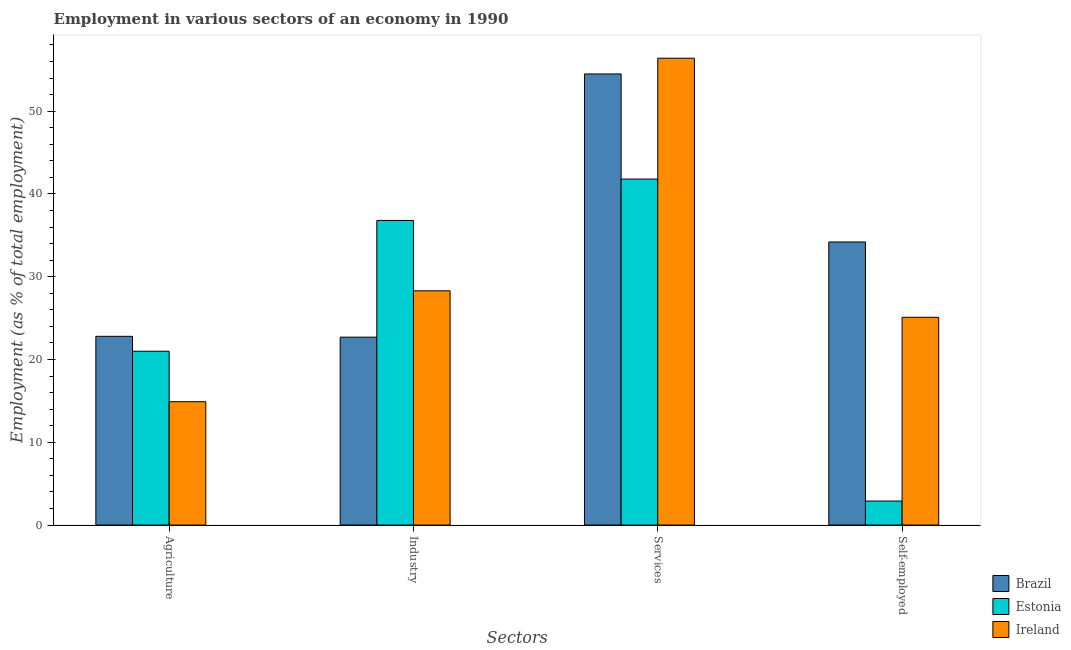Are the number of bars per tick equal to the number of legend labels?
Provide a succinct answer. Yes. Are the number of bars on each tick of the X-axis equal?
Your answer should be compact. Yes. How many bars are there on the 1st tick from the right?
Your answer should be very brief. 3. What is the label of the 4th group of bars from the left?
Your answer should be compact. Self-employed. What is the percentage of workers in industry in Ireland?
Your answer should be compact. 28.3. Across all countries, what is the maximum percentage of workers in agriculture?
Keep it short and to the point. 22.8. Across all countries, what is the minimum percentage of workers in services?
Provide a succinct answer. 41.8. In which country was the percentage of workers in industry maximum?
Keep it short and to the point. Estonia. In which country was the percentage of workers in agriculture minimum?
Offer a very short reply. Ireland. What is the total percentage of self employed workers in the graph?
Your answer should be very brief. 62.2. What is the difference between the percentage of workers in industry in Brazil and that in Estonia?
Give a very brief answer. -14.1. What is the difference between the percentage of workers in industry in Ireland and the percentage of self employed workers in Estonia?
Provide a succinct answer. 25.4. What is the average percentage of workers in industry per country?
Make the answer very short. 29.27. What is the difference between the percentage of workers in industry and percentage of workers in agriculture in Ireland?
Your answer should be very brief. 13.4. What is the ratio of the percentage of workers in agriculture in Estonia to that in Ireland?
Provide a short and direct response. 1.41. Is the difference between the percentage of workers in agriculture in Estonia and Ireland greater than the difference between the percentage of workers in services in Estonia and Ireland?
Make the answer very short. Yes. What is the difference between the highest and the second highest percentage of workers in industry?
Give a very brief answer. 8.5. What is the difference between the highest and the lowest percentage of workers in services?
Keep it short and to the point. 14.6. In how many countries, is the percentage of workers in services greater than the average percentage of workers in services taken over all countries?
Offer a very short reply. 2. Is the sum of the percentage of workers in services in Estonia and Brazil greater than the maximum percentage of self employed workers across all countries?
Offer a terse response. Yes. What does the 2nd bar from the left in Industry represents?
Keep it short and to the point. Estonia. What does the 2nd bar from the right in Agriculture represents?
Your answer should be very brief. Estonia. Is it the case that in every country, the sum of the percentage of workers in agriculture and percentage of workers in industry is greater than the percentage of workers in services?
Your answer should be compact. No. Are all the bars in the graph horizontal?
Your answer should be compact. No. How many countries are there in the graph?
Provide a succinct answer. 3. What is the difference between two consecutive major ticks on the Y-axis?
Keep it short and to the point. 10. Does the graph contain grids?
Provide a short and direct response. No. Where does the legend appear in the graph?
Give a very brief answer. Bottom right. How many legend labels are there?
Your answer should be very brief. 3. What is the title of the graph?
Provide a short and direct response. Employment in various sectors of an economy in 1990. Does "Belarus" appear as one of the legend labels in the graph?
Make the answer very short. No. What is the label or title of the X-axis?
Offer a very short reply. Sectors. What is the label or title of the Y-axis?
Keep it short and to the point. Employment (as % of total employment). What is the Employment (as % of total employment) of Brazil in Agriculture?
Your answer should be compact. 22.8. What is the Employment (as % of total employment) in Estonia in Agriculture?
Keep it short and to the point. 21. What is the Employment (as % of total employment) in Ireland in Agriculture?
Give a very brief answer. 14.9. What is the Employment (as % of total employment) of Brazil in Industry?
Offer a very short reply. 22.7. What is the Employment (as % of total employment) of Estonia in Industry?
Provide a succinct answer. 36.8. What is the Employment (as % of total employment) in Ireland in Industry?
Offer a very short reply. 28.3. What is the Employment (as % of total employment) of Brazil in Services?
Ensure brevity in your answer.  54.5. What is the Employment (as % of total employment) in Estonia in Services?
Keep it short and to the point. 41.8. What is the Employment (as % of total employment) in Ireland in Services?
Provide a short and direct response. 56.4. What is the Employment (as % of total employment) of Brazil in Self-employed?
Give a very brief answer. 34.2. What is the Employment (as % of total employment) of Estonia in Self-employed?
Provide a succinct answer. 2.9. What is the Employment (as % of total employment) in Ireland in Self-employed?
Ensure brevity in your answer.  25.1. Across all Sectors, what is the maximum Employment (as % of total employment) of Brazil?
Your answer should be compact. 54.5. Across all Sectors, what is the maximum Employment (as % of total employment) in Estonia?
Your answer should be very brief. 41.8. Across all Sectors, what is the maximum Employment (as % of total employment) of Ireland?
Provide a short and direct response. 56.4. Across all Sectors, what is the minimum Employment (as % of total employment) in Brazil?
Offer a very short reply. 22.7. Across all Sectors, what is the minimum Employment (as % of total employment) of Estonia?
Keep it short and to the point. 2.9. Across all Sectors, what is the minimum Employment (as % of total employment) of Ireland?
Your answer should be very brief. 14.9. What is the total Employment (as % of total employment) in Brazil in the graph?
Offer a very short reply. 134.2. What is the total Employment (as % of total employment) in Estonia in the graph?
Provide a short and direct response. 102.5. What is the total Employment (as % of total employment) in Ireland in the graph?
Your answer should be compact. 124.7. What is the difference between the Employment (as % of total employment) of Estonia in Agriculture and that in Industry?
Ensure brevity in your answer.  -15.8. What is the difference between the Employment (as % of total employment) in Ireland in Agriculture and that in Industry?
Ensure brevity in your answer.  -13.4. What is the difference between the Employment (as % of total employment) of Brazil in Agriculture and that in Services?
Provide a short and direct response. -31.7. What is the difference between the Employment (as % of total employment) in Estonia in Agriculture and that in Services?
Your answer should be compact. -20.8. What is the difference between the Employment (as % of total employment) of Ireland in Agriculture and that in Services?
Give a very brief answer. -41.5. What is the difference between the Employment (as % of total employment) in Ireland in Agriculture and that in Self-employed?
Your answer should be compact. -10.2. What is the difference between the Employment (as % of total employment) in Brazil in Industry and that in Services?
Your answer should be very brief. -31.8. What is the difference between the Employment (as % of total employment) of Ireland in Industry and that in Services?
Offer a terse response. -28.1. What is the difference between the Employment (as % of total employment) in Brazil in Industry and that in Self-employed?
Provide a succinct answer. -11.5. What is the difference between the Employment (as % of total employment) of Estonia in Industry and that in Self-employed?
Provide a succinct answer. 33.9. What is the difference between the Employment (as % of total employment) in Ireland in Industry and that in Self-employed?
Ensure brevity in your answer.  3.2. What is the difference between the Employment (as % of total employment) in Brazil in Services and that in Self-employed?
Provide a short and direct response. 20.3. What is the difference between the Employment (as % of total employment) in Estonia in Services and that in Self-employed?
Your answer should be very brief. 38.9. What is the difference between the Employment (as % of total employment) in Ireland in Services and that in Self-employed?
Your response must be concise. 31.3. What is the difference between the Employment (as % of total employment) in Brazil in Agriculture and the Employment (as % of total employment) in Estonia in Industry?
Your response must be concise. -14. What is the difference between the Employment (as % of total employment) in Estonia in Agriculture and the Employment (as % of total employment) in Ireland in Industry?
Your response must be concise. -7.3. What is the difference between the Employment (as % of total employment) in Brazil in Agriculture and the Employment (as % of total employment) in Ireland in Services?
Ensure brevity in your answer.  -33.6. What is the difference between the Employment (as % of total employment) in Estonia in Agriculture and the Employment (as % of total employment) in Ireland in Services?
Make the answer very short. -35.4. What is the difference between the Employment (as % of total employment) of Brazil in Agriculture and the Employment (as % of total employment) of Ireland in Self-employed?
Your response must be concise. -2.3. What is the difference between the Employment (as % of total employment) of Brazil in Industry and the Employment (as % of total employment) of Estonia in Services?
Offer a terse response. -19.1. What is the difference between the Employment (as % of total employment) of Brazil in Industry and the Employment (as % of total employment) of Ireland in Services?
Your answer should be compact. -33.7. What is the difference between the Employment (as % of total employment) in Estonia in Industry and the Employment (as % of total employment) in Ireland in Services?
Offer a terse response. -19.6. What is the difference between the Employment (as % of total employment) in Brazil in Industry and the Employment (as % of total employment) in Estonia in Self-employed?
Your response must be concise. 19.8. What is the difference between the Employment (as % of total employment) in Brazil in Industry and the Employment (as % of total employment) in Ireland in Self-employed?
Offer a terse response. -2.4. What is the difference between the Employment (as % of total employment) in Estonia in Industry and the Employment (as % of total employment) in Ireland in Self-employed?
Your answer should be very brief. 11.7. What is the difference between the Employment (as % of total employment) of Brazil in Services and the Employment (as % of total employment) of Estonia in Self-employed?
Ensure brevity in your answer.  51.6. What is the difference between the Employment (as % of total employment) in Brazil in Services and the Employment (as % of total employment) in Ireland in Self-employed?
Offer a very short reply. 29.4. What is the difference between the Employment (as % of total employment) of Estonia in Services and the Employment (as % of total employment) of Ireland in Self-employed?
Your answer should be very brief. 16.7. What is the average Employment (as % of total employment) in Brazil per Sectors?
Ensure brevity in your answer.  33.55. What is the average Employment (as % of total employment) in Estonia per Sectors?
Your response must be concise. 25.62. What is the average Employment (as % of total employment) in Ireland per Sectors?
Keep it short and to the point. 31.18. What is the difference between the Employment (as % of total employment) in Brazil and Employment (as % of total employment) in Estonia in Industry?
Make the answer very short. -14.1. What is the difference between the Employment (as % of total employment) in Brazil and Employment (as % of total employment) in Ireland in Services?
Give a very brief answer. -1.9. What is the difference between the Employment (as % of total employment) of Estonia and Employment (as % of total employment) of Ireland in Services?
Offer a very short reply. -14.6. What is the difference between the Employment (as % of total employment) of Brazil and Employment (as % of total employment) of Estonia in Self-employed?
Ensure brevity in your answer.  31.3. What is the difference between the Employment (as % of total employment) of Estonia and Employment (as % of total employment) of Ireland in Self-employed?
Provide a succinct answer. -22.2. What is the ratio of the Employment (as % of total employment) of Estonia in Agriculture to that in Industry?
Provide a short and direct response. 0.57. What is the ratio of the Employment (as % of total employment) in Ireland in Agriculture to that in Industry?
Keep it short and to the point. 0.53. What is the ratio of the Employment (as % of total employment) of Brazil in Agriculture to that in Services?
Ensure brevity in your answer.  0.42. What is the ratio of the Employment (as % of total employment) of Estonia in Agriculture to that in Services?
Your answer should be very brief. 0.5. What is the ratio of the Employment (as % of total employment) of Ireland in Agriculture to that in Services?
Your answer should be compact. 0.26. What is the ratio of the Employment (as % of total employment) of Estonia in Agriculture to that in Self-employed?
Provide a short and direct response. 7.24. What is the ratio of the Employment (as % of total employment) of Ireland in Agriculture to that in Self-employed?
Provide a succinct answer. 0.59. What is the ratio of the Employment (as % of total employment) in Brazil in Industry to that in Services?
Provide a short and direct response. 0.42. What is the ratio of the Employment (as % of total employment) of Estonia in Industry to that in Services?
Give a very brief answer. 0.88. What is the ratio of the Employment (as % of total employment) of Ireland in Industry to that in Services?
Give a very brief answer. 0.5. What is the ratio of the Employment (as % of total employment) of Brazil in Industry to that in Self-employed?
Your answer should be compact. 0.66. What is the ratio of the Employment (as % of total employment) of Estonia in Industry to that in Self-employed?
Provide a succinct answer. 12.69. What is the ratio of the Employment (as % of total employment) in Ireland in Industry to that in Self-employed?
Offer a terse response. 1.13. What is the ratio of the Employment (as % of total employment) of Brazil in Services to that in Self-employed?
Provide a succinct answer. 1.59. What is the ratio of the Employment (as % of total employment) in Estonia in Services to that in Self-employed?
Ensure brevity in your answer.  14.41. What is the ratio of the Employment (as % of total employment) of Ireland in Services to that in Self-employed?
Offer a terse response. 2.25. What is the difference between the highest and the second highest Employment (as % of total employment) of Brazil?
Provide a short and direct response. 20.3. What is the difference between the highest and the second highest Employment (as % of total employment) in Estonia?
Offer a terse response. 5. What is the difference between the highest and the second highest Employment (as % of total employment) in Ireland?
Keep it short and to the point. 28.1. What is the difference between the highest and the lowest Employment (as % of total employment) in Brazil?
Keep it short and to the point. 31.8. What is the difference between the highest and the lowest Employment (as % of total employment) in Estonia?
Ensure brevity in your answer.  38.9. What is the difference between the highest and the lowest Employment (as % of total employment) in Ireland?
Offer a terse response. 41.5. 